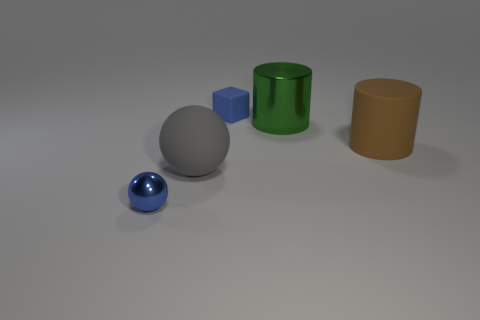Add 3 small red metallic blocks. How many objects exist? 8 Subtract all cylinders. How many objects are left? 3 Add 3 green shiny objects. How many green shiny objects are left? 4 Add 5 large rubber spheres. How many large rubber spheres exist? 6 Subtract 0 cyan cylinders. How many objects are left? 5 Subtract all purple shiny cylinders. Subtract all rubber things. How many objects are left? 2 